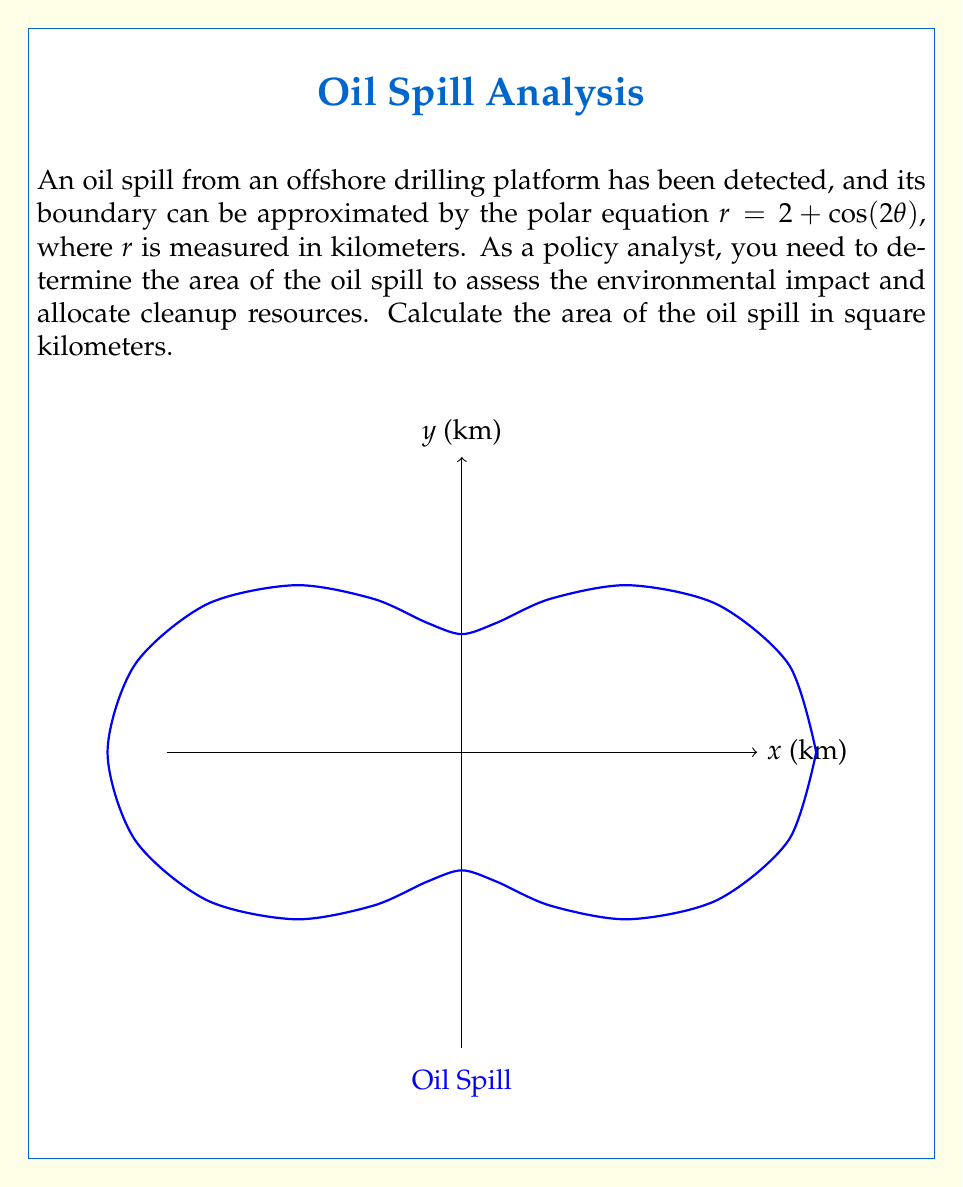Solve this math problem. To determine the area of the oil spill using polar coordinates, we'll follow these steps:

1) The formula for the area enclosed by a polar curve $r = f(\theta)$ from $\theta = a$ to $\theta = b$ is:

   $$A = \frac{1}{2} \int_{a}^{b} [f(\theta)]^2 d\theta$$

2) In our case, $f(\theta) = 2 + \cos(2\theta)$, $a = 0$, and $b = 2\pi$ (full rotation).

3) Let's substitute this into our formula:

   $$A = \frac{1}{2} \int_{0}^{2\pi} [2 + \cos(2\theta)]^2 d\theta$$

4) Expand the squared term:

   $$A = \frac{1}{2} \int_{0}^{2\pi} [4 + 4\cos(2\theta) + \cos^2(2\theta)] d\theta$$

5) Use the identity $\cos^2(x) = \frac{1}{2}[1 + \cos(2x)]$:

   $$A = \frac{1}{2} \int_{0}^{2\pi} [4 + 4\cos(2\theta) + \frac{1}{2} + \frac{1}{2}\cos(4\theta)] d\theta$$

6) Simplify:

   $$A = \frac{1}{2} \int_{0}^{2\pi} [4.5 + 4\cos(2\theta) + \frac{1}{2}\cos(4\theta)] d\theta$$

7) Integrate term by term:

   $$A = \frac{1}{2} [4.5\theta + 2\sin(2\theta) + \frac{1}{8}\sin(4\theta)]_0^{2\pi}$$

8) Evaluate the definite integral:

   $$A = \frac{1}{2} [(4.5 \cdot 2\pi + 0 + 0) - (0 + 0 + 0)]$$

9) Simplify:

   $$A = \frac{1}{2} \cdot 4.5 \cdot 2\pi = 4.5\pi$$

Therefore, the area of the oil spill is $4.5\pi$ square kilometers.
Answer: $4.5\pi$ sq km 